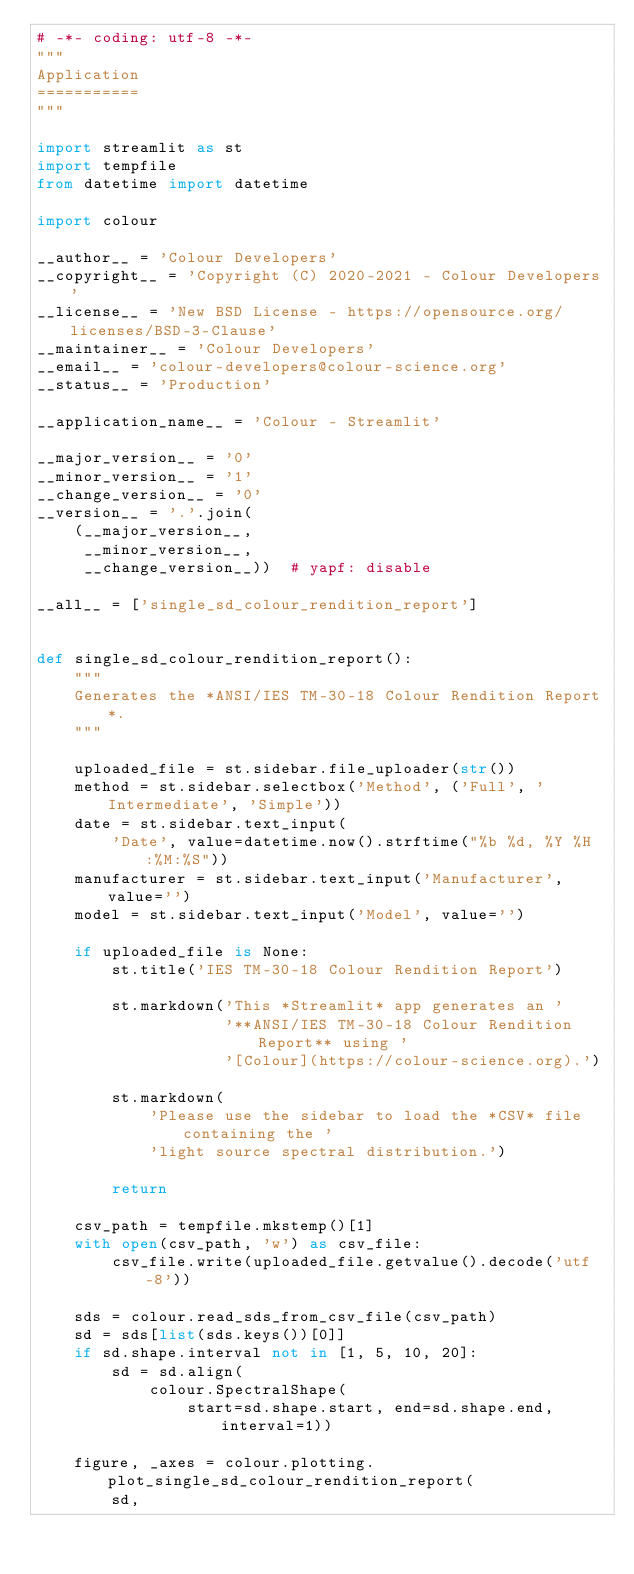<code> <loc_0><loc_0><loc_500><loc_500><_Python_># -*- coding: utf-8 -*-
"""
Application
===========
"""

import streamlit as st
import tempfile
from datetime import datetime

import colour

__author__ = 'Colour Developers'
__copyright__ = 'Copyright (C) 2020-2021 - Colour Developers'
__license__ = 'New BSD License - https://opensource.org/licenses/BSD-3-Clause'
__maintainer__ = 'Colour Developers'
__email__ = 'colour-developers@colour-science.org'
__status__ = 'Production'

__application_name__ = 'Colour - Streamlit'

__major_version__ = '0'
__minor_version__ = '1'
__change_version__ = '0'
__version__ = '.'.join(
    (__major_version__,
     __minor_version__,
     __change_version__))  # yapf: disable

__all__ = ['single_sd_colour_rendition_report']


def single_sd_colour_rendition_report():
    """
    Generates the *ANSI/IES TM-30-18 Colour Rendition Report*.
    """

    uploaded_file = st.sidebar.file_uploader(str())
    method = st.sidebar.selectbox('Method', ('Full', 'Intermediate', 'Simple'))
    date = st.sidebar.text_input(
        'Date', value=datetime.now().strftime("%b %d, %Y %H:%M:%S"))
    manufacturer = st.sidebar.text_input('Manufacturer', value='')
    model = st.sidebar.text_input('Model', value='')

    if uploaded_file is None:
        st.title('IES TM-30-18 Colour Rendition Report')

        st.markdown('This *Streamlit* app generates an '
                    '**ANSI/IES TM-30-18 Colour Rendition Report** using '
                    '[Colour](https://colour-science.org).')

        st.markdown(
            'Please use the sidebar to load the *CSV* file containing the '
            'light source spectral distribution.')

        return

    csv_path = tempfile.mkstemp()[1]
    with open(csv_path, 'w') as csv_file:
        csv_file.write(uploaded_file.getvalue().decode('utf-8'))

    sds = colour.read_sds_from_csv_file(csv_path)
    sd = sds[list(sds.keys())[0]]
    if sd.shape.interval not in [1, 5, 10, 20]:
        sd = sd.align(
            colour.SpectralShape(
                start=sd.shape.start, end=sd.shape.end, interval=1))

    figure, _axes = colour.plotting.plot_single_sd_colour_rendition_report(
        sd,</code> 